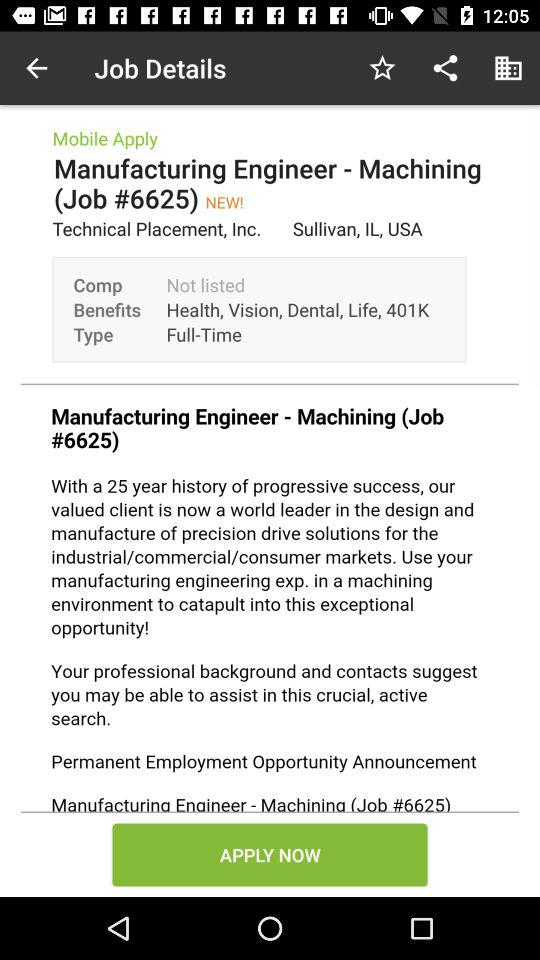What is the job title? The job title is manufacturing engineer. 